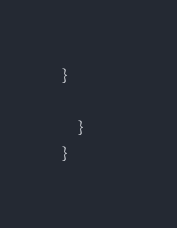<code> <loc_0><loc_0><loc_500><loc_500><_Java_>}
        
    }        
}
</code> 